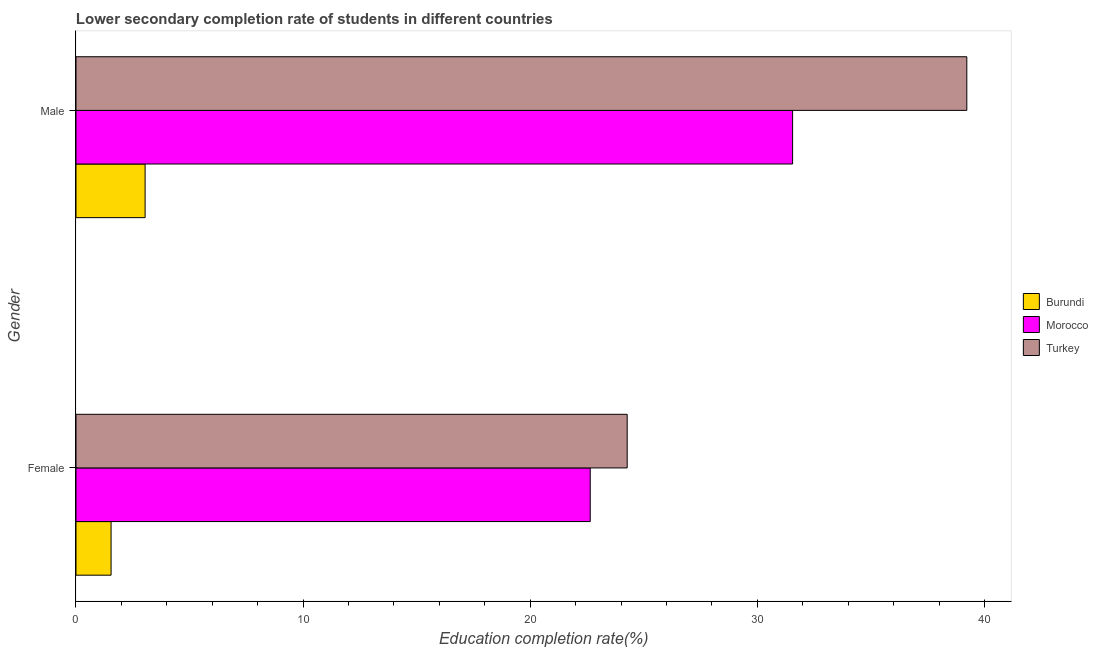Are the number of bars on each tick of the Y-axis equal?
Make the answer very short. Yes. How many bars are there on the 2nd tick from the top?
Give a very brief answer. 3. What is the education completion rate of male students in Turkey?
Keep it short and to the point. 39.22. Across all countries, what is the maximum education completion rate of male students?
Provide a short and direct response. 39.22. Across all countries, what is the minimum education completion rate of male students?
Give a very brief answer. 3.04. In which country was the education completion rate of female students maximum?
Your response must be concise. Turkey. In which country was the education completion rate of male students minimum?
Ensure brevity in your answer.  Burundi. What is the total education completion rate of female students in the graph?
Make the answer very short. 48.45. What is the difference between the education completion rate of male students in Turkey and that in Morocco?
Provide a succinct answer. 7.67. What is the difference between the education completion rate of male students in Burundi and the education completion rate of female students in Morocco?
Keep it short and to the point. -19.6. What is the average education completion rate of male students per country?
Your answer should be very brief. 24.6. What is the difference between the education completion rate of male students and education completion rate of female students in Morocco?
Offer a terse response. 8.91. What is the ratio of the education completion rate of male students in Morocco to that in Burundi?
Make the answer very short. 10.37. What does the 2nd bar from the top in Male represents?
Keep it short and to the point. Morocco. What does the 3rd bar from the bottom in Male represents?
Give a very brief answer. Turkey. How many bars are there?
Give a very brief answer. 6. Are all the bars in the graph horizontal?
Give a very brief answer. Yes. How many countries are there in the graph?
Offer a terse response. 3. Does the graph contain grids?
Offer a terse response. No. How are the legend labels stacked?
Keep it short and to the point. Vertical. What is the title of the graph?
Ensure brevity in your answer.  Lower secondary completion rate of students in different countries. What is the label or title of the X-axis?
Your answer should be compact. Education completion rate(%). What is the Education completion rate(%) in Burundi in Female?
Keep it short and to the point. 1.54. What is the Education completion rate(%) in Morocco in Female?
Give a very brief answer. 22.64. What is the Education completion rate(%) of Turkey in Female?
Provide a succinct answer. 24.27. What is the Education completion rate(%) in Burundi in Male?
Provide a short and direct response. 3.04. What is the Education completion rate(%) of Morocco in Male?
Keep it short and to the point. 31.55. What is the Education completion rate(%) in Turkey in Male?
Keep it short and to the point. 39.22. Across all Gender, what is the maximum Education completion rate(%) of Burundi?
Ensure brevity in your answer.  3.04. Across all Gender, what is the maximum Education completion rate(%) of Morocco?
Provide a short and direct response. 31.55. Across all Gender, what is the maximum Education completion rate(%) in Turkey?
Your response must be concise. 39.22. Across all Gender, what is the minimum Education completion rate(%) in Burundi?
Ensure brevity in your answer.  1.54. Across all Gender, what is the minimum Education completion rate(%) of Morocco?
Offer a very short reply. 22.64. Across all Gender, what is the minimum Education completion rate(%) in Turkey?
Your response must be concise. 24.27. What is the total Education completion rate(%) of Burundi in the graph?
Provide a succinct answer. 4.59. What is the total Education completion rate(%) in Morocco in the graph?
Your answer should be compact. 54.19. What is the total Education completion rate(%) of Turkey in the graph?
Offer a very short reply. 63.49. What is the difference between the Education completion rate(%) of Burundi in Female and that in Male?
Offer a very short reply. -1.5. What is the difference between the Education completion rate(%) of Morocco in Female and that in Male?
Offer a terse response. -8.91. What is the difference between the Education completion rate(%) in Turkey in Female and that in Male?
Your response must be concise. -14.95. What is the difference between the Education completion rate(%) of Burundi in Female and the Education completion rate(%) of Morocco in Male?
Your answer should be very brief. -30.01. What is the difference between the Education completion rate(%) of Burundi in Female and the Education completion rate(%) of Turkey in Male?
Offer a terse response. -37.67. What is the difference between the Education completion rate(%) of Morocco in Female and the Education completion rate(%) of Turkey in Male?
Offer a terse response. -16.58. What is the average Education completion rate(%) in Burundi per Gender?
Make the answer very short. 2.29. What is the average Education completion rate(%) of Morocco per Gender?
Ensure brevity in your answer.  27.1. What is the average Education completion rate(%) of Turkey per Gender?
Offer a very short reply. 31.74. What is the difference between the Education completion rate(%) of Burundi and Education completion rate(%) of Morocco in Female?
Give a very brief answer. -21.1. What is the difference between the Education completion rate(%) of Burundi and Education completion rate(%) of Turkey in Female?
Your response must be concise. -22.72. What is the difference between the Education completion rate(%) of Morocco and Education completion rate(%) of Turkey in Female?
Provide a short and direct response. -1.63. What is the difference between the Education completion rate(%) of Burundi and Education completion rate(%) of Morocco in Male?
Your answer should be compact. -28.51. What is the difference between the Education completion rate(%) of Burundi and Education completion rate(%) of Turkey in Male?
Keep it short and to the point. -36.18. What is the difference between the Education completion rate(%) of Morocco and Education completion rate(%) of Turkey in Male?
Ensure brevity in your answer.  -7.67. What is the ratio of the Education completion rate(%) of Burundi in Female to that in Male?
Offer a terse response. 0.51. What is the ratio of the Education completion rate(%) of Morocco in Female to that in Male?
Make the answer very short. 0.72. What is the ratio of the Education completion rate(%) of Turkey in Female to that in Male?
Offer a terse response. 0.62. What is the difference between the highest and the second highest Education completion rate(%) in Burundi?
Offer a very short reply. 1.5. What is the difference between the highest and the second highest Education completion rate(%) in Morocco?
Give a very brief answer. 8.91. What is the difference between the highest and the second highest Education completion rate(%) in Turkey?
Offer a terse response. 14.95. What is the difference between the highest and the lowest Education completion rate(%) of Burundi?
Your answer should be very brief. 1.5. What is the difference between the highest and the lowest Education completion rate(%) of Morocco?
Make the answer very short. 8.91. What is the difference between the highest and the lowest Education completion rate(%) in Turkey?
Give a very brief answer. 14.95. 